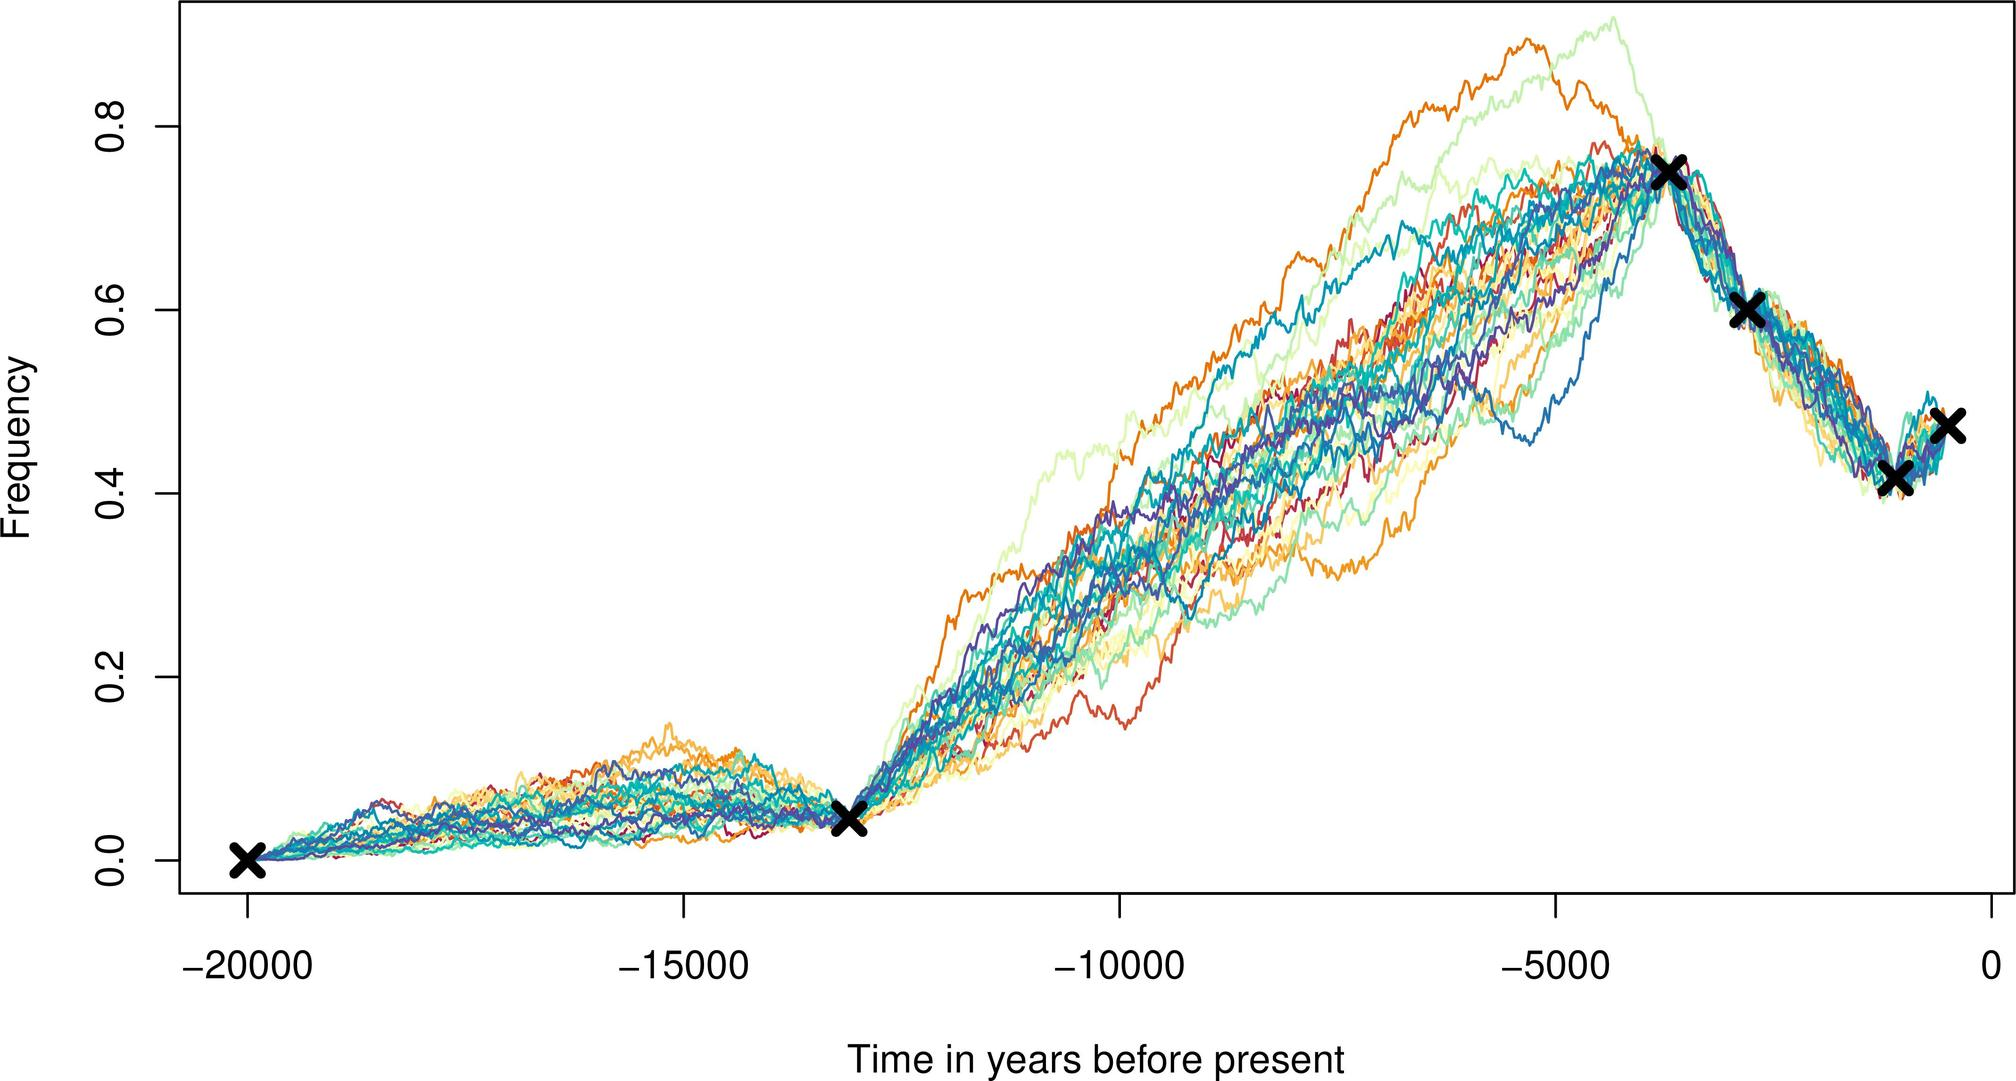What does the clustering of crosses towards the right end of the graph suggest? A convergence of data towards a common event or time period. Anomalies in the data sets. Random placement of data markers. Discrepancies between the data sets. - The crosses are grouped closely together towards the right end of the graph, indicating that the data sets converge or are in agreement about the frequency of the event during that time period. Therefore, the correct answer is A. 